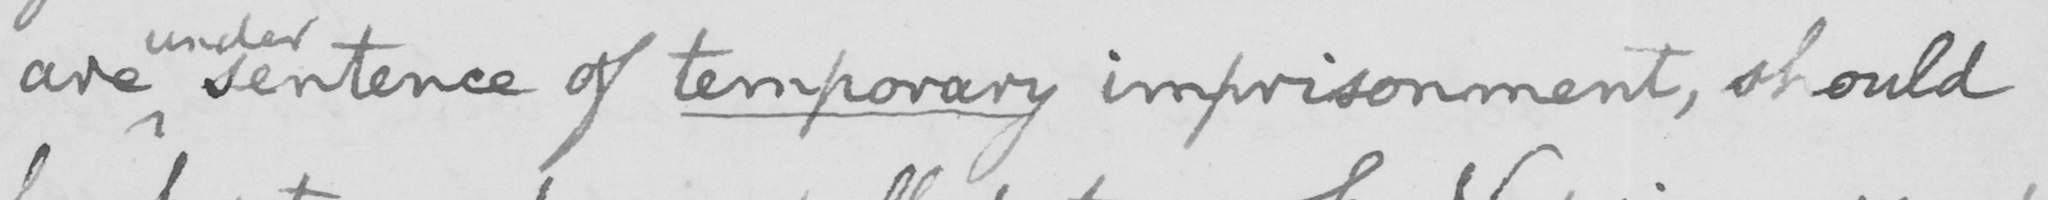What is written in this line of handwriting? are sentence of temporary imprisonment, should 